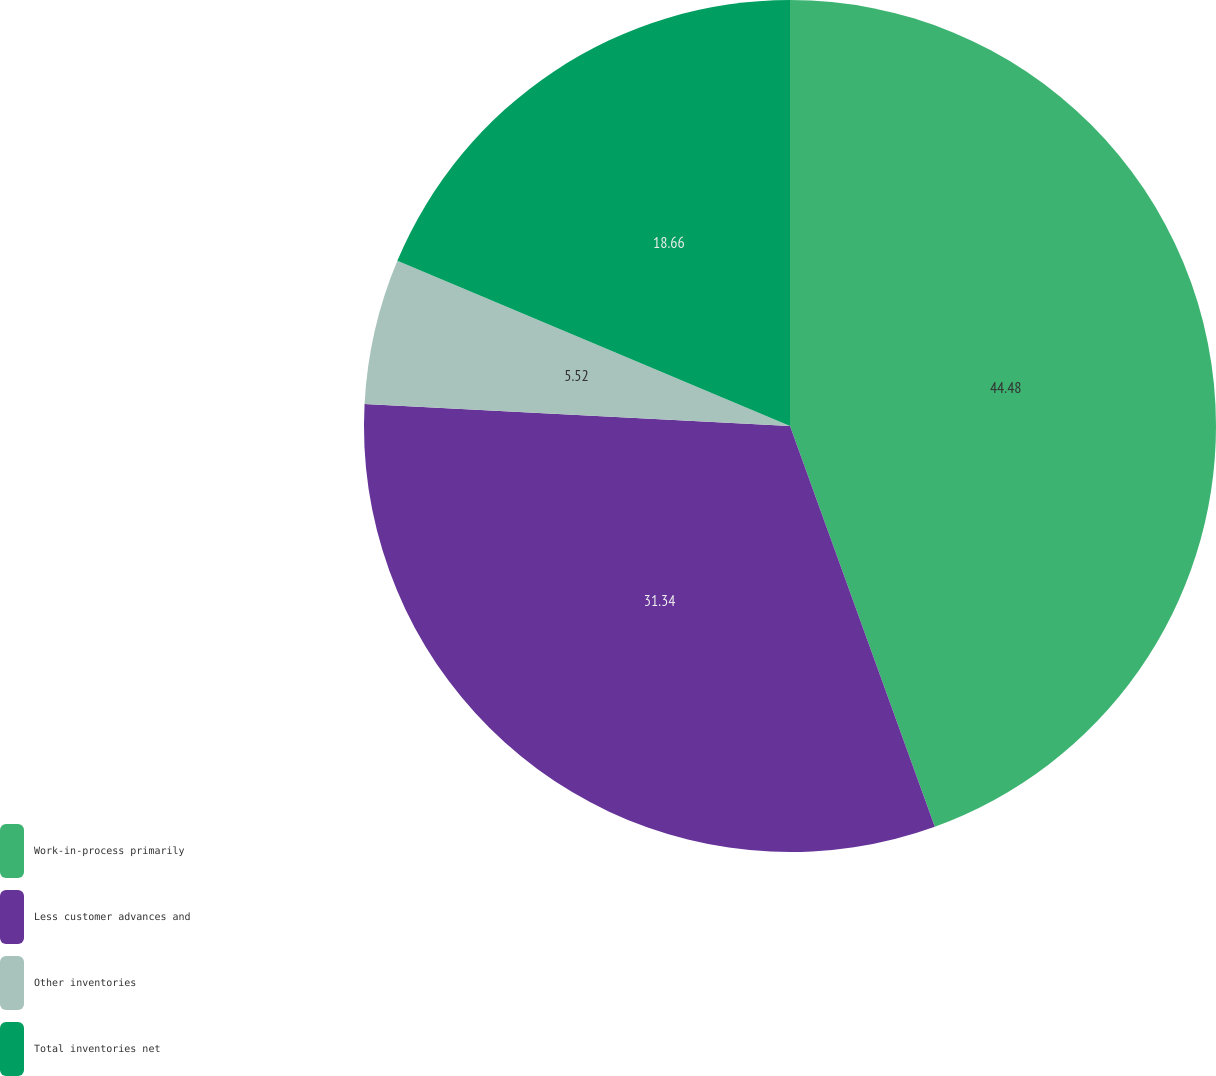Convert chart. <chart><loc_0><loc_0><loc_500><loc_500><pie_chart><fcel>Work-in-process primarily<fcel>Less customer advances and<fcel>Other inventories<fcel>Total inventories net<nl><fcel>44.48%<fcel>31.34%<fcel>5.52%<fcel>18.66%<nl></chart> 